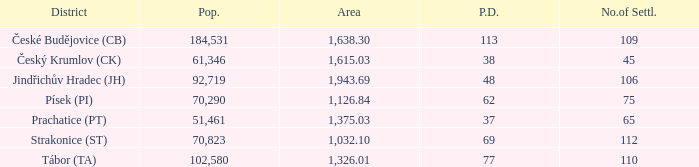How big is the area that has a population density of 113 and a population larger than 184,531? 0.0. 